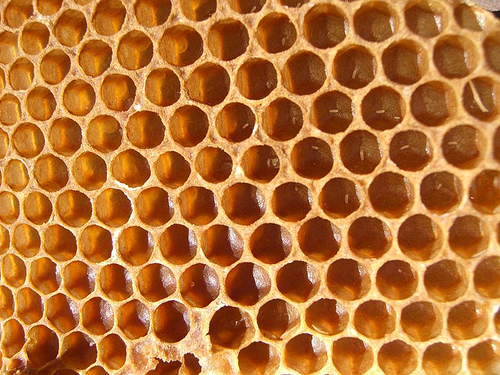<image>
Is the hole to the right of the hole? No. The hole is not to the right of the hole. The horizontal positioning shows a different relationship. 